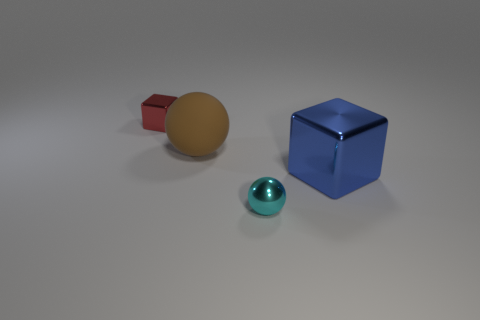There is a small cyan object that is the same shape as the big brown matte thing; what is its material?
Offer a terse response. Metal. What shape is the cyan thing that is made of the same material as the tiny red cube?
Provide a short and direct response. Sphere. Do the tiny thing in front of the red metal thing and the block to the right of the tiny red shiny thing have the same material?
Ensure brevity in your answer.  Yes. What number of objects are either big green cylinders or shiny cubes on the right side of the brown sphere?
Ensure brevity in your answer.  1. Is there anything else that has the same material as the brown thing?
Your response must be concise. No. What is the tiny sphere made of?
Ensure brevity in your answer.  Metal. Does the big block have the same material as the cyan thing?
Offer a very short reply. Yes. What number of metal things are either brown balls or big purple blocks?
Give a very brief answer. 0. The large blue shiny thing on the right side of the small block has what shape?
Ensure brevity in your answer.  Cube. There is a cyan thing that is the same material as the red thing; what size is it?
Offer a very short reply. Small. 